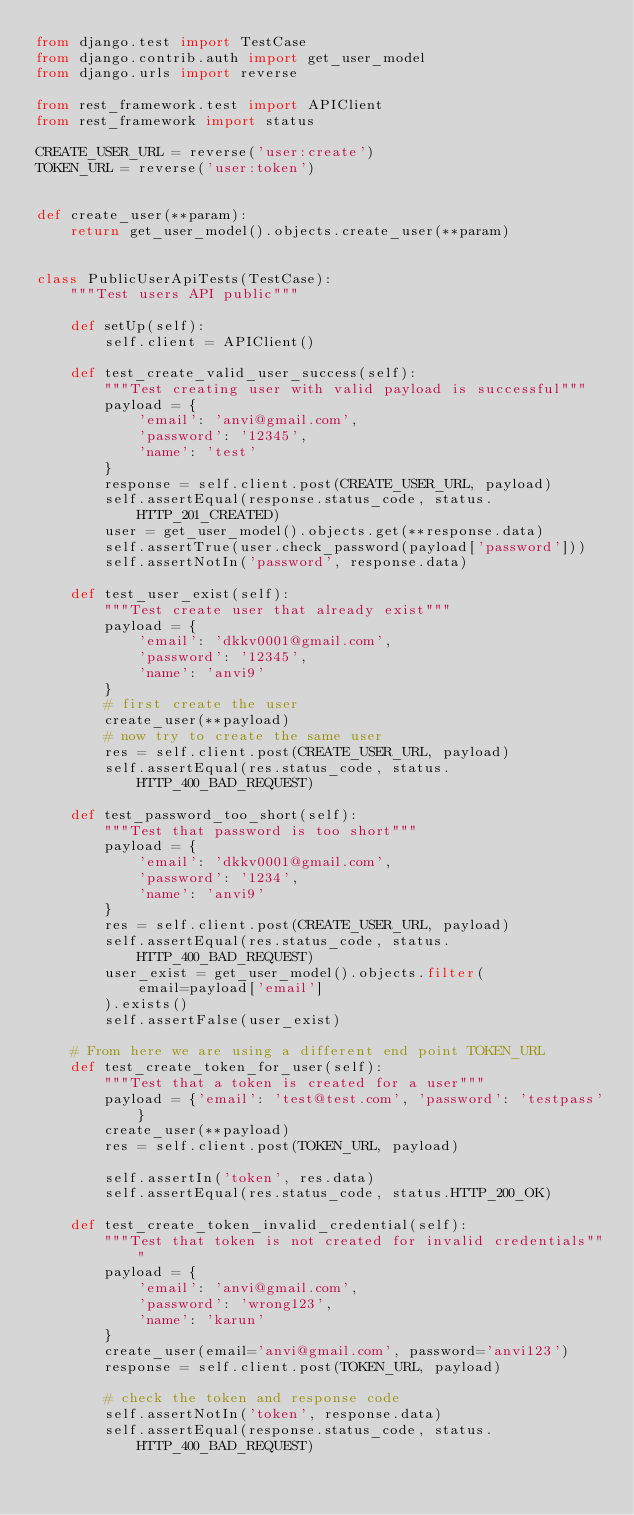Convert code to text. <code><loc_0><loc_0><loc_500><loc_500><_Python_>from django.test import TestCase
from django.contrib.auth import get_user_model
from django.urls import reverse

from rest_framework.test import APIClient
from rest_framework import status

CREATE_USER_URL = reverse('user:create')
TOKEN_URL = reverse('user:token')


def create_user(**param):
    return get_user_model().objects.create_user(**param)


class PublicUserApiTests(TestCase):
    """Test users API public"""

    def setUp(self):
        self.client = APIClient()

    def test_create_valid_user_success(self):
        """Test creating user with valid payload is successful"""
        payload = {
            'email': 'anvi@gmail.com',
            'password': '12345',
            'name': 'test'
        }
        response = self.client.post(CREATE_USER_URL, payload)
        self.assertEqual(response.status_code, status.HTTP_201_CREATED)
        user = get_user_model().objects.get(**response.data)
        self.assertTrue(user.check_password(payload['password']))
        self.assertNotIn('password', response.data)

    def test_user_exist(self):
        """Test create user that already exist"""
        payload = {
            'email': 'dkkv0001@gmail.com',
            'password': '12345',
            'name': 'anvi9'
        }
        # first create the user
        create_user(**payload)
        # now try to create the same user
        res = self.client.post(CREATE_USER_URL, payload)
        self.assertEqual(res.status_code, status.HTTP_400_BAD_REQUEST)

    def test_password_too_short(self):
        """Test that password is too short"""
        payload = {
            'email': 'dkkv0001@gmail.com',
            'password': '1234',
            'name': 'anvi9'
        }
        res = self.client.post(CREATE_USER_URL, payload)
        self.assertEqual(res.status_code, status.HTTP_400_BAD_REQUEST)
        user_exist = get_user_model().objects.filter(
            email=payload['email']
        ).exists()
        self.assertFalse(user_exist)

    # From here we are using a different end point TOKEN_URL
    def test_create_token_for_user(self):
        """Test that a token is created for a user"""
        payload = {'email': 'test@test.com', 'password': 'testpass'}
        create_user(**payload)
        res = self.client.post(TOKEN_URL, payload)

        self.assertIn('token', res.data)
        self.assertEqual(res.status_code, status.HTTP_200_OK)

    def test_create_token_invalid_credential(self):
        """Test that token is not created for invalid credentials"""
        payload = {
            'email': 'anvi@gmail.com',
            'password': 'wrong123',
            'name': 'karun'
        }
        create_user(email='anvi@gmail.com', password='anvi123')
        response = self.client.post(TOKEN_URL, payload)

        # check the token and response code
        self.assertNotIn('token', response.data)
        self.assertEqual(response.status_code, status.HTTP_400_BAD_REQUEST)
</code> 